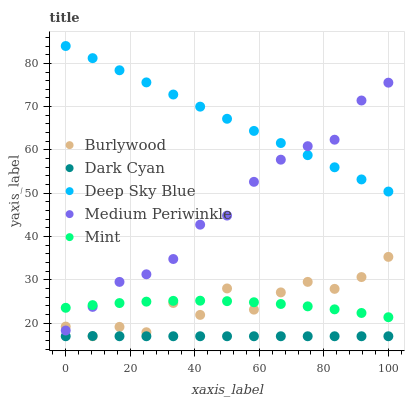Does Dark Cyan have the minimum area under the curve?
Answer yes or no. Yes. Does Deep Sky Blue have the maximum area under the curve?
Answer yes or no. Yes. Does Medium Periwinkle have the minimum area under the curve?
Answer yes or no. No. Does Medium Periwinkle have the maximum area under the curve?
Answer yes or no. No. Is Deep Sky Blue the smoothest?
Answer yes or no. Yes. Is Burlywood the roughest?
Answer yes or no. Yes. Is Dark Cyan the smoothest?
Answer yes or no. No. Is Dark Cyan the roughest?
Answer yes or no. No. Does Burlywood have the lowest value?
Answer yes or no. Yes. Does Medium Periwinkle have the lowest value?
Answer yes or no. No. Does Deep Sky Blue have the highest value?
Answer yes or no. Yes. Does Medium Periwinkle have the highest value?
Answer yes or no. No. Is Dark Cyan less than Deep Sky Blue?
Answer yes or no. Yes. Is Mint greater than Dark Cyan?
Answer yes or no. Yes. Does Mint intersect Burlywood?
Answer yes or no. Yes. Is Mint less than Burlywood?
Answer yes or no. No. Is Mint greater than Burlywood?
Answer yes or no. No. Does Dark Cyan intersect Deep Sky Blue?
Answer yes or no. No. 